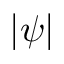Convert formula to latex. <formula><loc_0><loc_0><loc_500><loc_500>| \psi |</formula> 